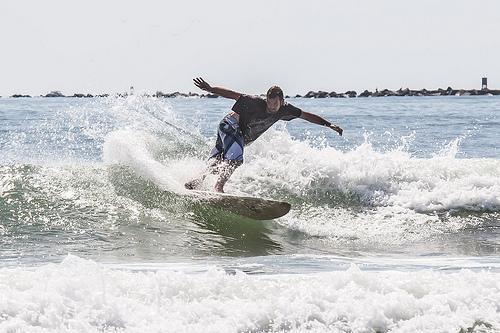How many men are in the water?
Give a very brief answer. 1. How many people are surfing?
Give a very brief answer. 1. How many people are visible in this photo?
Give a very brief answer. 1. 